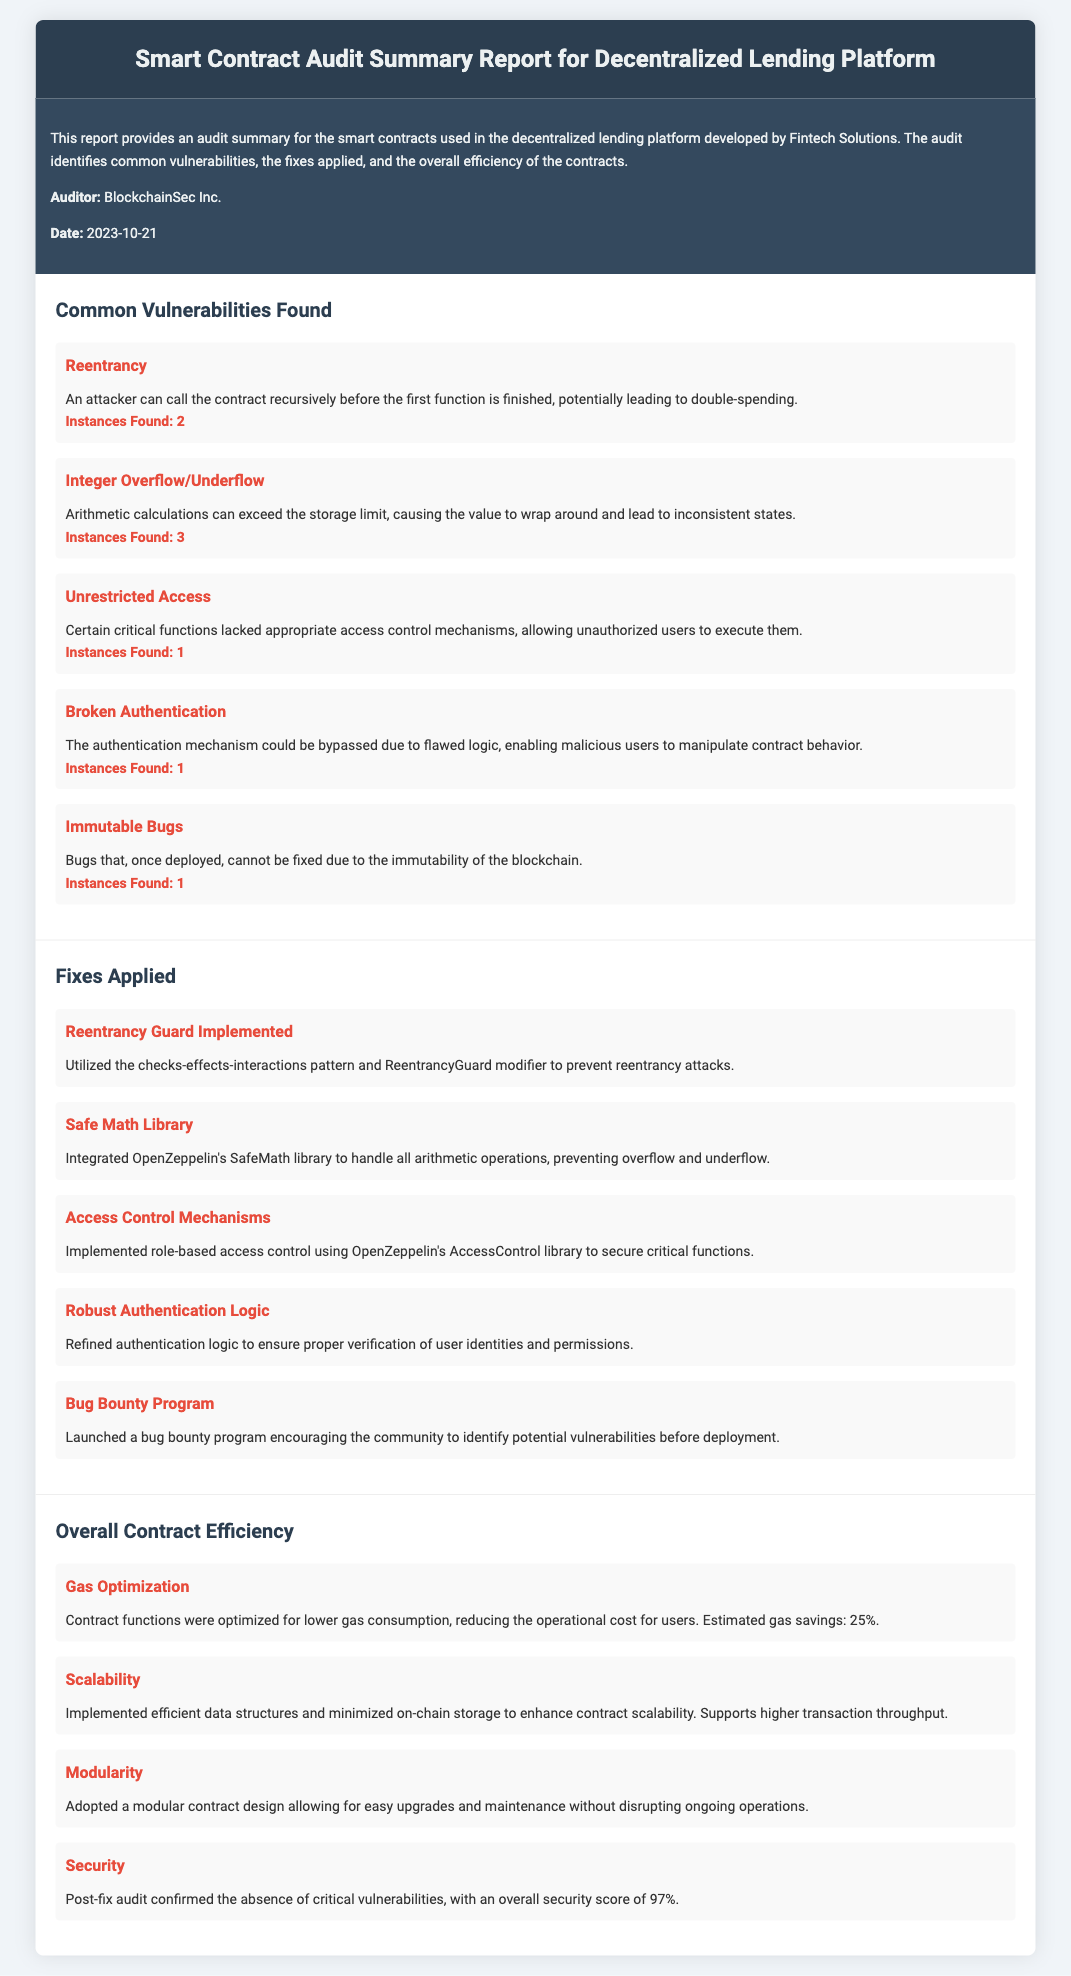What is the date of the audit report? The date of the audit report is mentioned in the overview section of the document.
Answer: 2023-10-21 How many instances of Reentrancy were found? The number of instances found for Reentrancy is listed under the common vulnerabilities section.
Answer: 2 What mechanism was implemented to prevent reentrancy attacks? The fixes applied section specifies the method used to counteract reentrancy attacks.
Answer: Reentrancy Guard What library was integrated to prevent integer overflow and underflow? The document states the specific library employed to handle arithmetic operations safely.
Answer: Safe Math Library What is the security score after the post-fix audit? The security score is provided in the overall contract efficiency section, highlighting the improvement post-fix.
Answer: 97% What is one of the enhancements made for contract scalability? The overall contract efficiency section mentions measures taken to improve scalability and transaction throughput.
Answer: Efficient data structures How many critical functions lacked appropriate access control? The number of critical functions without proper access control mechanisms is listed under common vulnerabilities.
Answer: 1 What percentage of gas savings was estimated from the optimizations? The estimated gas savings from contract optimizations is mentioned in the overall contract efficiency area.
Answer: 25% 